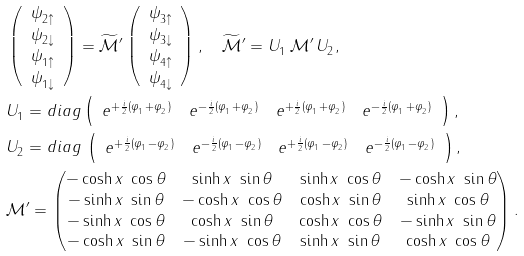Convert formula to latex. <formula><loc_0><loc_0><loc_500><loc_500>& \left ( \begin{array} { c } \psi ^ { \ } _ { 2 \uparrow } \\ \psi ^ { \ } _ { 2 \downarrow } \\ \psi ^ { \ } _ { 1 \uparrow } \\ \psi ^ { \ } _ { 1 \downarrow } \end{array} \right ) = \widetilde { \mathcal { M } } ^ { \prime } \left ( \begin{array} { c } \psi ^ { \ } _ { 3 \uparrow } \\ \psi ^ { \ } _ { 3 \downarrow } \\ \psi ^ { \ } _ { 4 \uparrow } \\ \psi ^ { \ } _ { 4 \downarrow } \end{array} \right ) , \quad \widetilde { \mathcal { M } } ^ { \prime } = U ^ { \ } _ { 1 } \, \mathcal { M } ^ { \prime } \, U ^ { \ } _ { 2 } , \\ & U ^ { \ } _ { 1 } = d i a g \left ( \begin{array} { c c c c } e ^ { + \frac { i } { 2 } ( \varphi ^ { \ } _ { 1 } + \varphi ^ { \ } _ { 2 } ) } & e ^ { - \frac { i } { 2 } ( \varphi ^ { \ } _ { 1 } + \varphi ^ { \ } _ { 2 } ) } & e ^ { + \frac { i } { 2 } ( \varphi ^ { \ } _ { 1 } + \varphi ^ { \ } _ { 2 } ) } & e ^ { - \frac { i } { 2 } ( \varphi ^ { \ } _ { 1 } + \varphi ^ { \ } _ { 2 } ) } \end{array} \right ) , \\ & U ^ { \ } _ { 2 } = d i a g \, \left ( \begin{array} { c c c c } e ^ { + \frac { i } { 2 } ( \varphi ^ { \ } _ { 1 } - \varphi ^ { \ } _ { 2 } ) } & e ^ { - \frac { i } { 2 } ( \varphi ^ { \ } _ { 1 } - \varphi ^ { \ } _ { 2 } ) } & e ^ { + \frac { i } { 2 } ( \varphi ^ { \ } _ { 1 } - \varphi ^ { \ } _ { 2 } ) } & e ^ { - \frac { i } { 2 } ( \varphi ^ { \ } _ { 1 } - \varphi ^ { \ } _ { 2 } ) } \end{array} \right ) , \\ & \mathcal { M } ^ { \prime } = \begin{pmatrix} - \cosh x \ \cos \theta & \sinh x \ \sin \theta & \sinh x \ \cos \theta & - \cosh x \ \sin \theta \\ - \sinh x \ \sin \theta & - \cosh x \ \cos \theta & \cosh x \ \sin \theta & \sinh x \ \cos \theta \\ - \sinh x \ \cos \theta & \cosh x \ \sin \theta & \cosh x \ \cos \theta & - \sinh x \ \sin \theta \\ - \cosh x \ \sin \theta & - \sinh x \ \cos \theta & \sinh x \ \sin \theta & \cosh x \ \cos \theta \end{pmatrix} .</formula> 